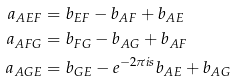<formula> <loc_0><loc_0><loc_500><loc_500>\label l { C - 2 - c o c - s y s t e m } a _ { A E F } & = b _ { E F } - b _ { A F } + b _ { A E } \\ a _ { A F G } & = b _ { F G } - b _ { A G } + b _ { A F } \\ a _ { A G E } & = b _ { G E } - e ^ { - 2 \pi i s } b _ { A E } + b _ { A G }</formula> 